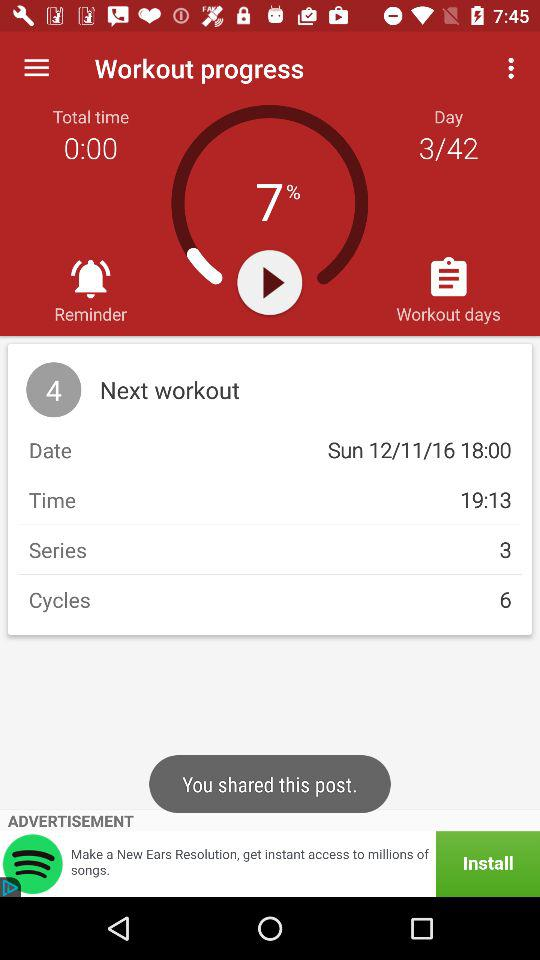Which workout day is it now? It is the third day of workout. 